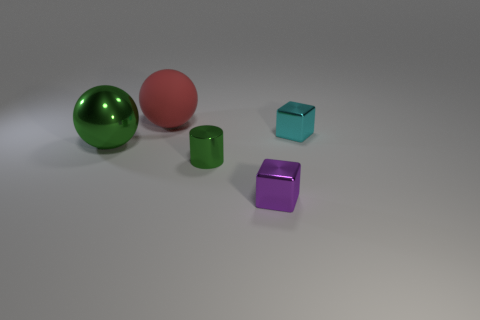Add 2 small purple blocks. How many objects exist? 7 Subtract all spheres. How many objects are left? 3 Subtract 0 yellow cylinders. How many objects are left? 5 Subtract all tiny purple metal cylinders. Subtract all cylinders. How many objects are left? 4 Add 3 small metal objects. How many small metal objects are left? 6 Add 2 large purple balls. How many large purple balls exist? 2 